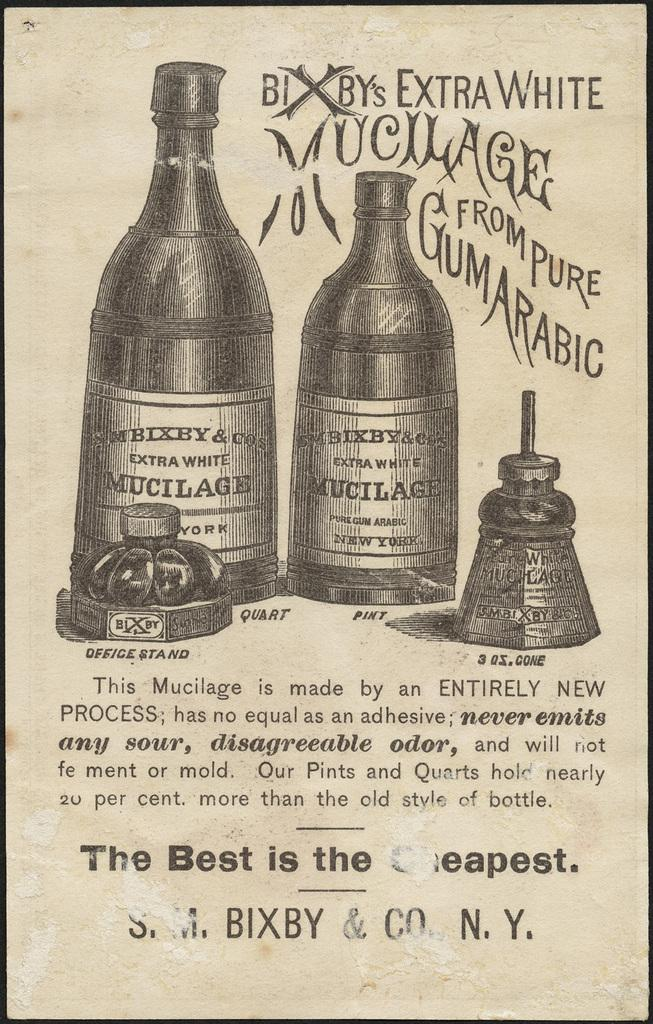<image>
Present a compact description of the photo's key features. the word white is at the top of the drink paper 